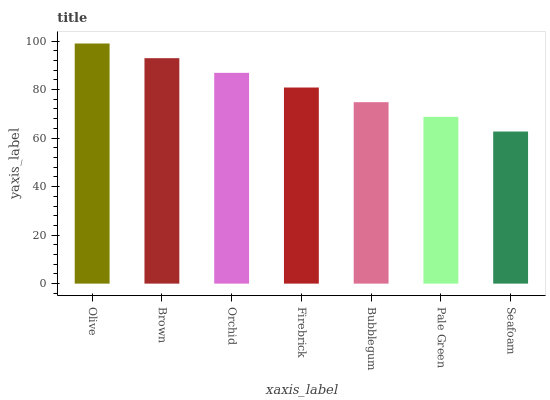Is Brown the minimum?
Answer yes or no. No. Is Brown the maximum?
Answer yes or no. No. Is Olive greater than Brown?
Answer yes or no. Yes. Is Brown less than Olive?
Answer yes or no. Yes. Is Brown greater than Olive?
Answer yes or no. No. Is Olive less than Brown?
Answer yes or no. No. Is Firebrick the high median?
Answer yes or no. Yes. Is Firebrick the low median?
Answer yes or no. Yes. Is Orchid the high median?
Answer yes or no. No. Is Orchid the low median?
Answer yes or no. No. 